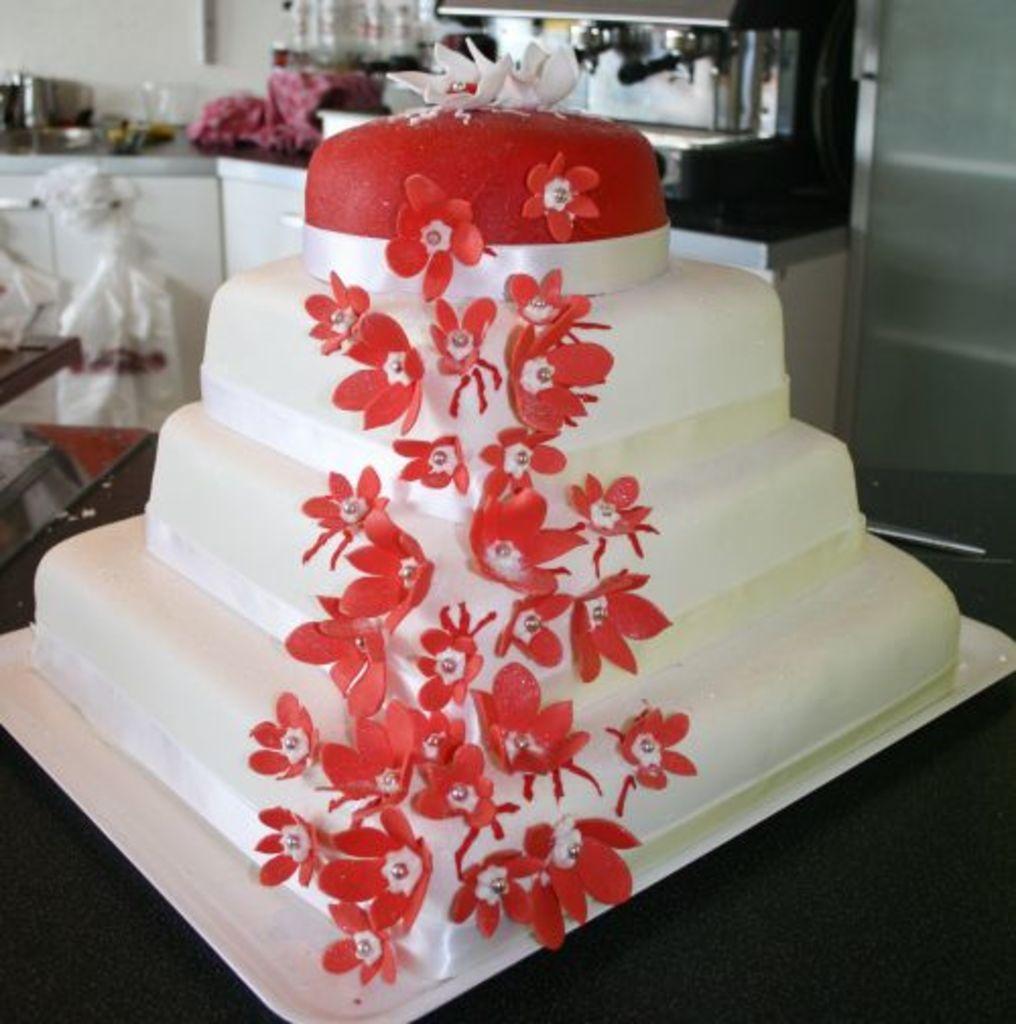In one or two sentences, can you explain what this image depicts? In this picture there is a cake in the foreground and the cake is in red and white color and there are red color flowers on the cake. At the back there are utensils on the table and there is a machine and there is a cloth on the table. There are objects on the table and there are covers on the cupboard. 